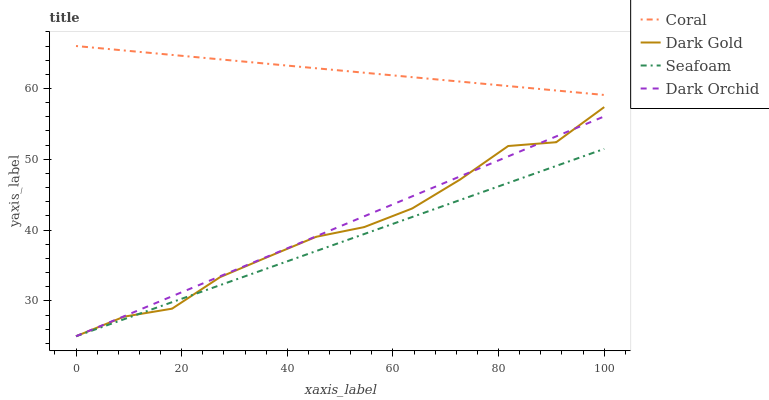Does Dark Orchid have the minimum area under the curve?
Answer yes or no. No. Does Dark Orchid have the maximum area under the curve?
Answer yes or no. No. Is Dark Orchid the smoothest?
Answer yes or no. No. Is Dark Orchid the roughest?
Answer yes or no. No. Does Dark Orchid have the highest value?
Answer yes or no. No. Is Dark Orchid less than Coral?
Answer yes or no. Yes. Is Coral greater than Seafoam?
Answer yes or no. Yes. Does Dark Orchid intersect Coral?
Answer yes or no. No. 